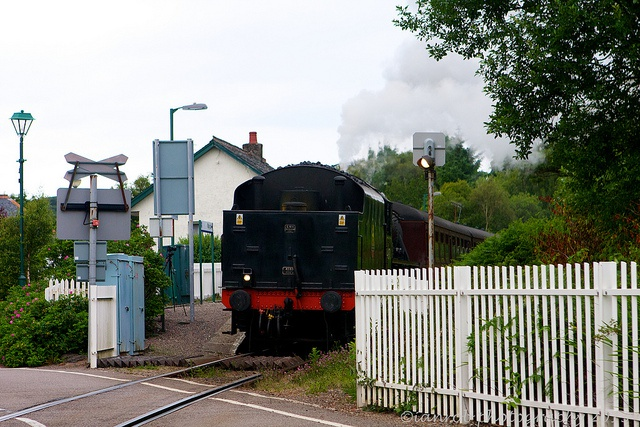Describe the objects in this image and their specific colors. I can see train in white, black, maroon, and gray tones and traffic light in white, black, ivory, gray, and maroon tones in this image. 